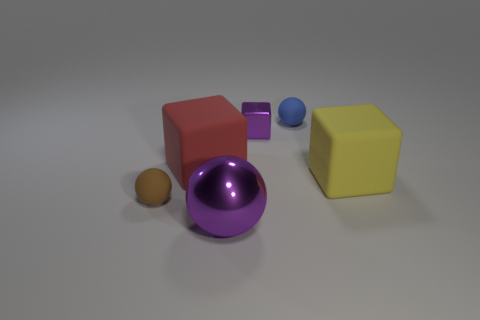There is a big object that is the same color as the small cube; what shape is it?
Offer a terse response. Sphere. What number of objects are either purple metallic things that are right of the big purple metallic object or balls in front of the red object?
Give a very brief answer. 3. How many big yellow rubber objects are the same shape as the red thing?
Your answer should be very brief. 1. There is a shiny cube that is the same size as the blue rubber ball; what color is it?
Give a very brief answer. Purple. There is a metallic thing behind the matte ball on the left side of the large thing left of the big shiny thing; what color is it?
Provide a succinct answer. Purple. There is a blue matte thing; is its size the same as the block that is to the right of the small blue thing?
Your response must be concise. No. What number of objects are either big green shiny balls or big blocks?
Provide a succinct answer. 2. Is there a gray object that has the same material as the red cube?
Keep it short and to the point. No. What is the size of the other metallic object that is the same color as the tiny metal object?
Make the answer very short. Large. There is a matte sphere that is right of the purple shiny object in front of the tiny purple object; what color is it?
Your answer should be compact. Blue. 